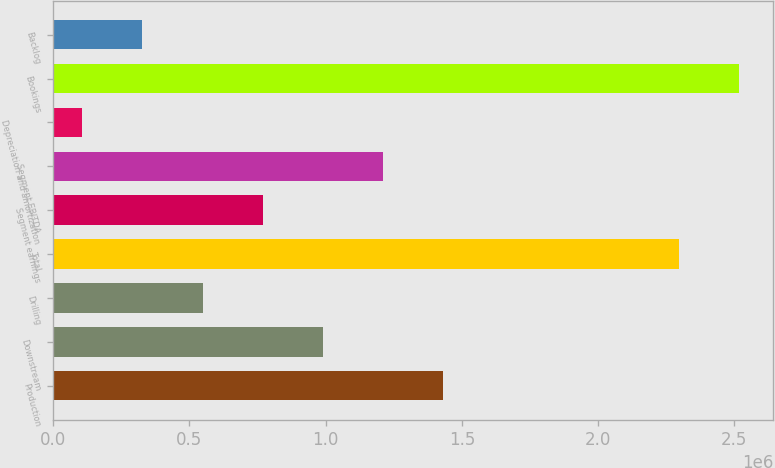Convert chart to OTSL. <chart><loc_0><loc_0><loc_500><loc_500><bar_chart><fcel>Production<fcel>Downstream<fcel>Drilling<fcel>Total<fcel>Segment earnings<fcel>Segment EBITDA<fcel>Depreciation and amortization<fcel>Bookings<fcel>Backlog<nl><fcel>1.43082e+06<fcel>989659<fcel>548502<fcel>2.29645e+06<fcel>769080<fcel>1.21024e+06<fcel>107344<fcel>2.51703e+06<fcel>327923<nl></chart> 